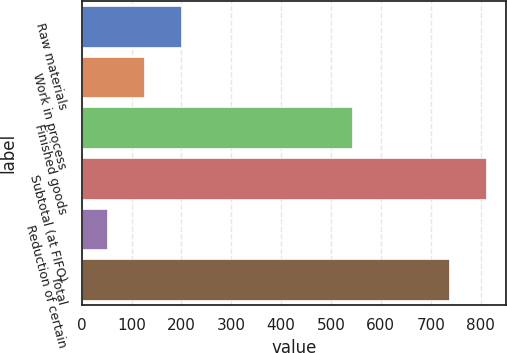<chart> <loc_0><loc_0><loc_500><loc_500><bar_chart><fcel>Raw materials<fcel>Work in process<fcel>Finished goods<fcel>Subtotal (at FIFO)<fcel>Reduction of certain<fcel>Total<nl><fcel>198.68<fcel>125.04<fcel>542.4<fcel>810.04<fcel>51.4<fcel>736.4<nl></chart> 